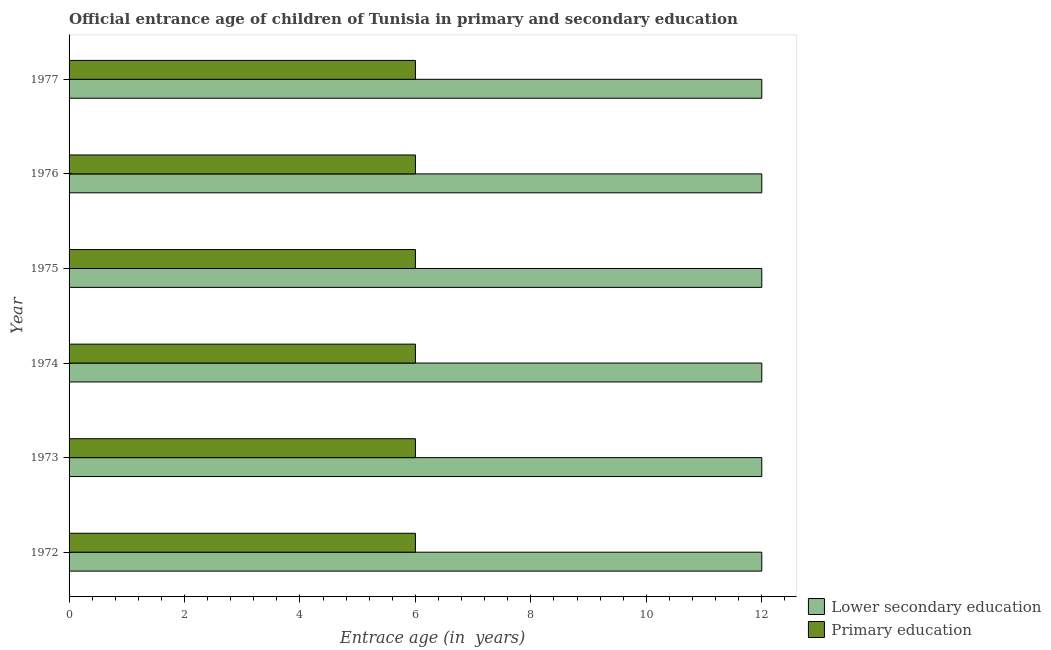How many groups of bars are there?
Keep it short and to the point. 6. Are the number of bars per tick equal to the number of legend labels?
Provide a succinct answer. Yes. Are the number of bars on each tick of the Y-axis equal?
Offer a terse response. Yes. How many bars are there on the 1st tick from the top?
Ensure brevity in your answer.  2. What is the label of the 6th group of bars from the top?
Make the answer very short. 1972. In how many cases, is the number of bars for a given year not equal to the number of legend labels?
Ensure brevity in your answer.  0. What is the entrance age of chiildren in primary education in 1973?
Make the answer very short. 6. Across all years, what is the minimum entrance age of children in lower secondary education?
Your answer should be very brief. 12. In which year was the entrance age of children in lower secondary education minimum?
Provide a short and direct response. 1972. What is the total entrance age of chiildren in primary education in the graph?
Offer a very short reply. 36. What is the difference between the entrance age of chiildren in primary education in 1975 and the entrance age of children in lower secondary education in 1976?
Offer a very short reply. -6. Is the entrance age of chiildren in primary education in 1975 less than that in 1977?
Your answer should be compact. No. What does the 2nd bar from the top in 1976 represents?
Give a very brief answer. Lower secondary education. What does the 1st bar from the bottom in 1973 represents?
Your answer should be compact. Lower secondary education. How many bars are there?
Give a very brief answer. 12. How many years are there in the graph?
Provide a succinct answer. 6. What is the difference between two consecutive major ticks on the X-axis?
Provide a short and direct response. 2. Does the graph contain any zero values?
Offer a very short reply. No. Does the graph contain grids?
Provide a short and direct response. No. Where does the legend appear in the graph?
Provide a succinct answer. Bottom right. How many legend labels are there?
Keep it short and to the point. 2. How are the legend labels stacked?
Offer a very short reply. Vertical. What is the title of the graph?
Your answer should be compact. Official entrance age of children of Tunisia in primary and secondary education. Does "Agricultural land" appear as one of the legend labels in the graph?
Offer a terse response. No. What is the label or title of the X-axis?
Keep it short and to the point. Entrace age (in  years). What is the Entrace age (in  years) in Lower secondary education in 1972?
Offer a terse response. 12. What is the Entrace age (in  years) in Primary education in 1972?
Your answer should be compact. 6. What is the Entrace age (in  years) of Lower secondary education in 1974?
Your response must be concise. 12. What is the Entrace age (in  years) in Lower secondary education in 1975?
Ensure brevity in your answer.  12. What is the Entrace age (in  years) in Primary education in 1975?
Your answer should be compact. 6. What is the Entrace age (in  years) in Primary education in 1976?
Give a very brief answer. 6. What is the Entrace age (in  years) in Lower secondary education in 1977?
Offer a very short reply. 12. What is the Entrace age (in  years) in Primary education in 1977?
Offer a very short reply. 6. Across all years, what is the maximum Entrace age (in  years) in Lower secondary education?
Keep it short and to the point. 12. Across all years, what is the minimum Entrace age (in  years) in Primary education?
Make the answer very short. 6. What is the total Entrace age (in  years) of Lower secondary education in the graph?
Provide a succinct answer. 72. What is the total Entrace age (in  years) of Primary education in the graph?
Ensure brevity in your answer.  36. What is the difference between the Entrace age (in  years) of Lower secondary education in 1972 and that in 1973?
Your response must be concise. 0. What is the difference between the Entrace age (in  years) of Primary education in 1972 and that in 1973?
Ensure brevity in your answer.  0. What is the difference between the Entrace age (in  years) in Lower secondary education in 1972 and that in 1974?
Ensure brevity in your answer.  0. What is the difference between the Entrace age (in  years) in Primary education in 1972 and that in 1974?
Your answer should be compact. 0. What is the difference between the Entrace age (in  years) of Lower secondary education in 1972 and that in 1975?
Your answer should be very brief. 0. What is the difference between the Entrace age (in  years) of Primary education in 1972 and that in 1975?
Provide a succinct answer. 0. What is the difference between the Entrace age (in  years) of Lower secondary education in 1972 and that in 1976?
Your answer should be compact. 0. What is the difference between the Entrace age (in  years) in Primary education in 1972 and that in 1976?
Make the answer very short. 0. What is the difference between the Entrace age (in  years) in Lower secondary education in 1973 and that in 1974?
Offer a very short reply. 0. What is the difference between the Entrace age (in  years) in Primary education in 1973 and that in 1974?
Offer a terse response. 0. What is the difference between the Entrace age (in  years) of Primary education in 1973 and that in 1975?
Ensure brevity in your answer.  0. What is the difference between the Entrace age (in  years) in Lower secondary education in 1973 and that in 1976?
Ensure brevity in your answer.  0. What is the difference between the Entrace age (in  years) in Lower secondary education in 1973 and that in 1977?
Provide a succinct answer. 0. What is the difference between the Entrace age (in  years) of Primary education in 1973 and that in 1977?
Give a very brief answer. 0. What is the difference between the Entrace age (in  years) of Primary education in 1974 and that in 1976?
Your answer should be very brief. 0. What is the difference between the Entrace age (in  years) of Lower secondary education in 1975 and that in 1976?
Make the answer very short. 0. What is the difference between the Entrace age (in  years) of Lower secondary education in 1975 and that in 1977?
Offer a very short reply. 0. What is the difference between the Entrace age (in  years) of Primary education in 1975 and that in 1977?
Ensure brevity in your answer.  0. What is the difference between the Entrace age (in  years) of Primary education in 1976 and that in 1977?
Offer a terse response. 0. What is the difference between the Entrace age (in  years) of Lower secondary education in 1972 and the Entrace age (in  years) of Primary education in 1975?
Your answer should be very brief. 6. What is the difference between the Entrace age (in  years) of Lower secondary education in 1972 and the Entrace age (in  years) of Primary education in 1977?
Provide a short and direct response. 6. What is the difference between the Entrace age (in  years) in Lower secondary education in 1973 and the Entrace age (in  years) in Primary education in 1976?
Provide a short and direct response. 6. What is the difference between the Entrace age (in  years) in Lower secondary education in 1973 and the Entrace age (in  years) in Primary education in 1977?
Provide a short and direct response. 6. What is the difference between the Entrace age (in  years) of Lower secondary education in 1974 and the Entrace age (in  years) of Primary education in 1977?
Provide a succinct answer. 6. What is the difference between the Entrace age (in  years) in Lower secondary education in 1975 and the Entrace age (in  years) in Primary education in 1976?
Keep it short and to the point. 6. What is the difference between the Entrace age (in  years) in Lower secondary education in 1975 and the Entrace age (in  years) in Primary education in 1977?
Your answer should be very brief. 6. In the year 1975, what is the difference between the Entrace age (in  years) of Lower secondary education and Entrace age (in  years) of Primary education?
Make the answer very short. 6. What is the ratio of the Entrace age (in  years) in Lower secondary education in 1972 to that in 1973?
Ensure brevity in your answer.  1. What is the ratio of the Entrace age (in  years) of Lower secondary education in 1972 to that in 1974?
Your answer should be compact. 1. What is the ratio of the Entrace age (in  years) in Primary education in 1972 to that in 1974?
Your response must be concise. 1. What is the ratio of the Entrace age (in  years) of Primary education in 1972 to that in 1975?
Give a very brief answer. 1. What is the ratio of the Entrace age (in  years) of Primary education in 1972 to that in 1976?
Provide a succinct answer. 1. What is the ratio of the Entrace age (in  years) of Lower secondary education in 1972 to that in 1977?
Offer a terse response. 1. What is the ratio of the Entrace age (in  years) of Primary education in 1972 to that in 1977?
Give a very brief answer. 1. What is the ratio of the Entrace age (in  years) in Lower secondary education in 1973 to that in 1974?
Make the answer very short. 1. What is the ratio of the Entrace age (in  years) of Primary education in 1973 to that in 1974?
Offer a very short reply. 1. What is the ratio of the Entrace age (in  years) in Lower secondary education in 1973 to that in 1975?
Give a very brief answer. 1. What is the ratio of the Entrace age (in  years) of Primary education in 1973 to that in 1976?
Your response must be concise. 1. What is the ratio of the Entrace age (in  years) in Primary education in 1973 to that in 1977?
Give a very brief answer. 1. What is the ratio of the Entrace age (in  years) in Primary education in 1974 to that in 1975?
Offer a very short reply. 1. What is the ratio of the Entrace age (in  years) of Lower secondary education in 1974 to that in 1976?
Ensure brevity in your answer.  1. What is the ratio of the Entrace age (in  years) of Primary education in 1974 to that in 1977?
Provide a succinct answer. 1. What is the ratio of the Entrace age (in  years) in Lower secondary education in 1975 to that in 1976?
Your answer should be compact. 1. What is the ratio of the Entrace age (in  years) of Primary education in 1975 to that in 1976?
Offer a very short reply. 1. What is the ratio of the Entrace age (in  years) in Primary education in 1975 to that in 1977?
Offer a very short reply. 1. What is the difference between the highest and the second highest Entrace age (in  years) of Lower secondary education?
Keep it short and to the point. 0. What is the difference between the highest and the second highest Entrace age (in  years) of Primary education?
Make the answer very short. 0. 